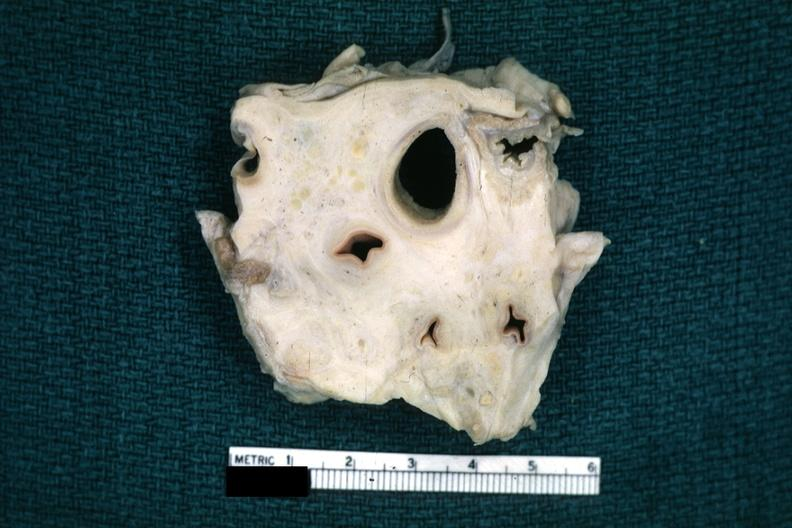what is present?
Answer the question using a single word or phrase. Thorax 